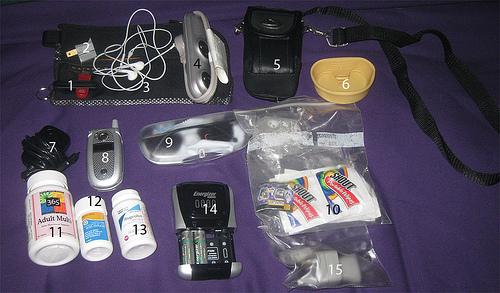What is item number 8?
Write a very short answer. Cell phone. How many items are numbered?
Be succinct. 15. What is this a picture of?
Write a very short answer. Travelling items. How many batteries are in the charger?
Write a very short answer. 2. 